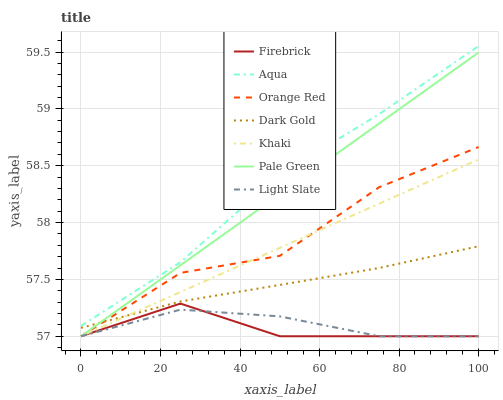Does Firebrick have the minimum area under the curve?
Answer yes or no. Yes. Does Aqua have the maximum area under the curve?
Answer yes or no. Yes. Does Dark Gold have the minimum area under the curve?
Answer yes or no. No. Does Dark Gold have the maximum area under the curve?
Answer yes or no. No. Is Khaki the smoothest?
Answer yes or no. Yes. Is Orange Red the roughest?
Answer yes or no. Yes. Is Dark Gold the smoothest?
Answer yes or no. No. Is Dark Gold the roughest?
Answer yes or no. No. Does Khaki have the lowest value?
Answer yes or no. Yes. Does Dark Gold have the lowest value?
Answer yes or no. No. Does Aqua have the highest value?
Answer yes or no. Yes. Does Dark Gold have the highest value?
Answer yes or no. No. Is Orange Red less than Aqua?
Answer yes or no. Yes. Is Aqua greater than Pale Green?
Answer yes or no. Yes. Does Firebrick intersect Light Slate?
Answer yes or no. Yes. Is Firebrick less than Light Slate?
Answer yes or no. No. Is Firebrick greater than Light Slate?
Answer yes or no. No. Does Orange Red intersect Aqua?
Answer yes or no. No. 